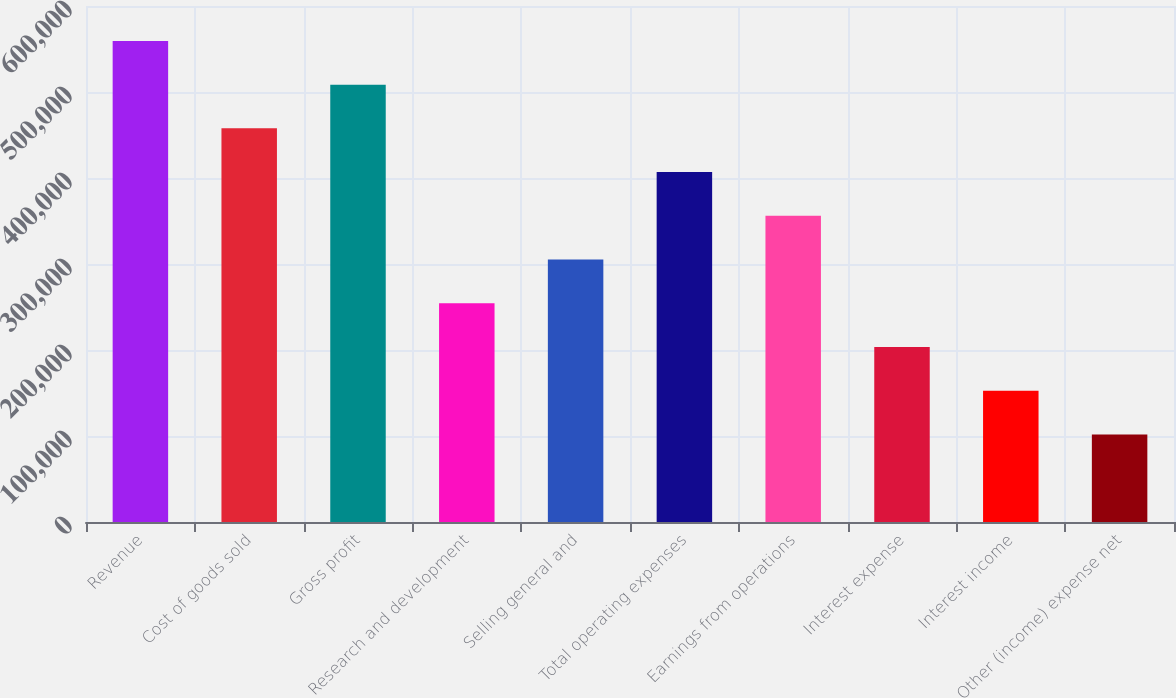<chart> <loc_0><loc_0><loc_500><loc_500><bar_chart><fcel>Revenue<fcel>Cost of goods sold<fcel>Gross profit<fcel>Research and development<fcel>Selling general and<fcel>Total operating expenses<fcel>Earnings from operations<fcel>Interest expense<fcel>Interest income<fcel>Other (income) expense net<nl><fcel>559417<fcel>457705<fcel>508561<fcel>254281<fcel>305137<fcel>406849<fcel>355993<fcel>203425<fcel>152569<fcel>101713<nl></chart> 